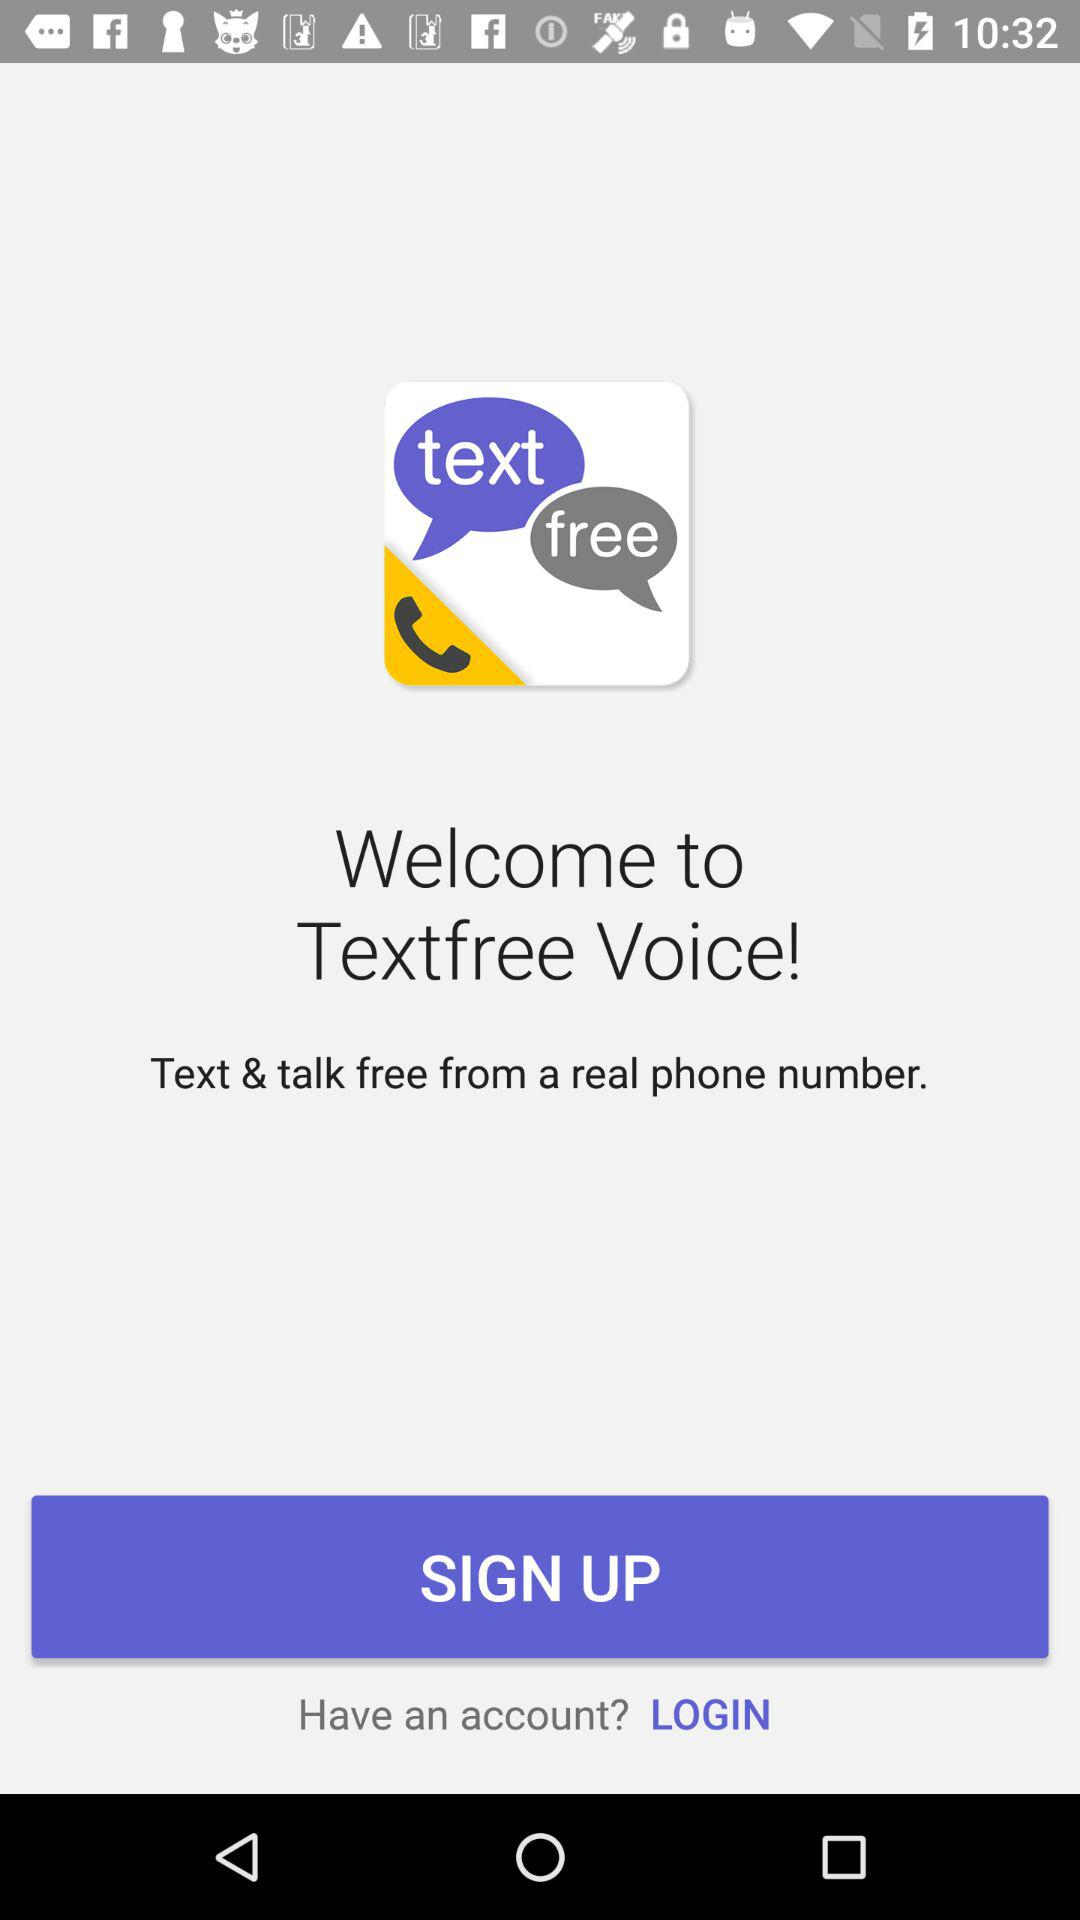What is the phone number?
When the provided information is insufficient, respond with <no answer>. <no answer> 